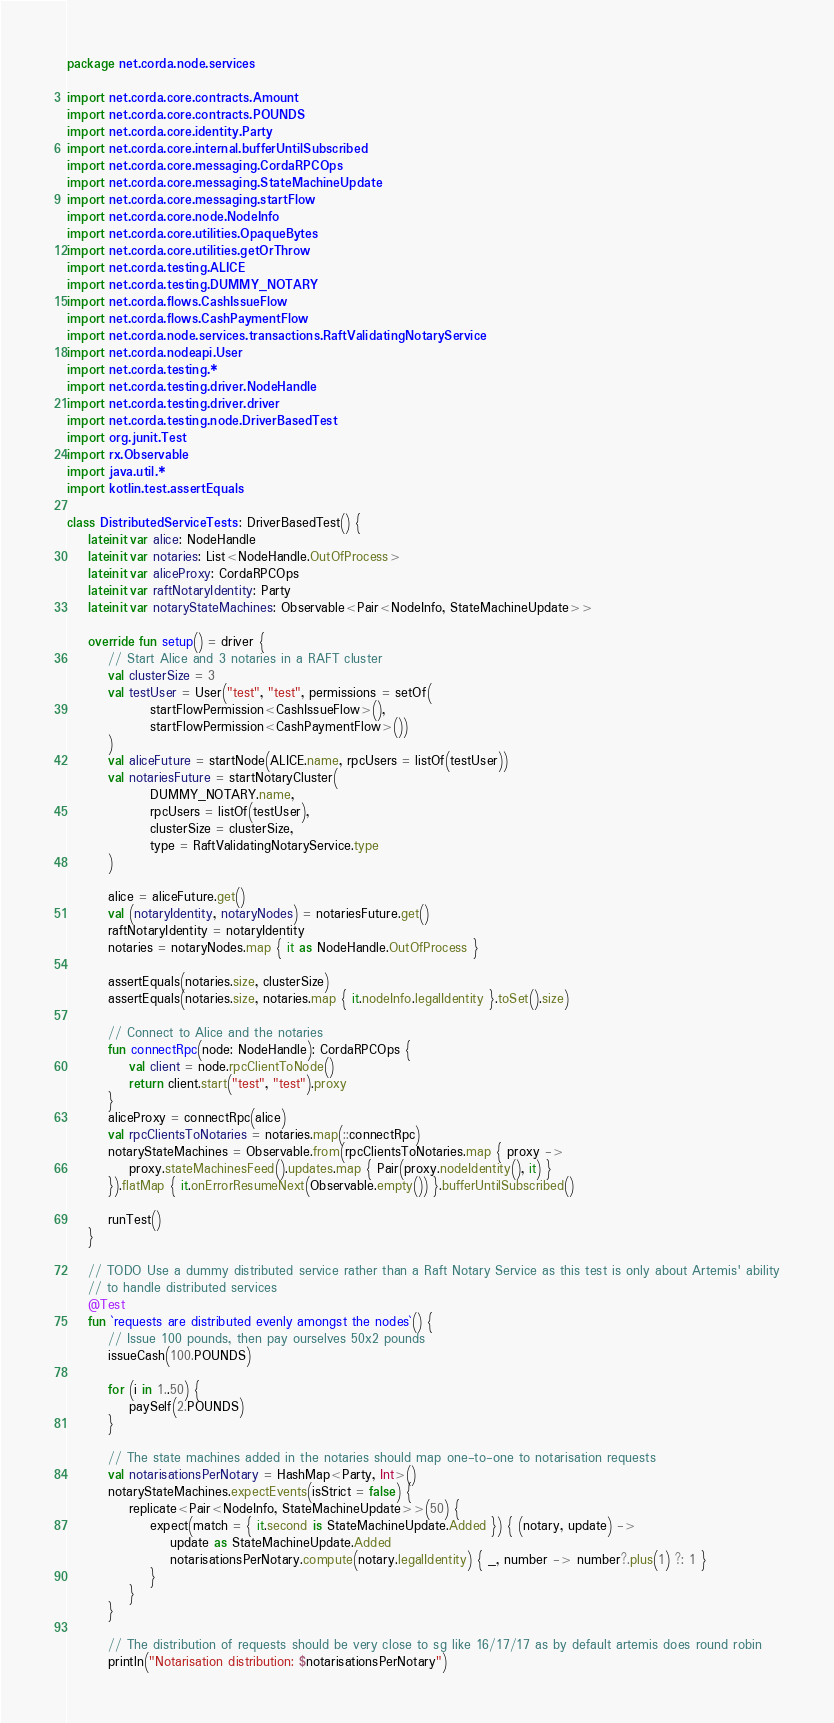Convert code to text. <code><loc_0><loc_0><loc_500><loc_500><_Kotlin_>package net.corda.node.services

import net.corda.core.contracts.Amount
import net.corda.core.contracts.POUNDS
import net.corda.core.identity.Party
import net.corda.core.internal.bufferUntilSubscribed
import net.corda.core.messaging.CordaRPCOps
import net.corda.core.messaging.StateMachineUpdate
import net.corda.core.messaging.startFlow
import net.corda.core.node.NodeInfo
import net.corda.core.utilities.OpaqueBytes
import net.corda.core.utilities.getOrThrow
import net.corda.testing.ALICE
import net.corda.testing.DUMMY_NOTARY
import net.corda.flows.CashIssueFlow
import net.corda.flows.CashPaymentFlow
import net.corda.node.services.transactions.RaftValidatingNotaryService
import net.corda.nodeapi.User
import net.corda.testing.*
import net.corda.testing.driver.NodeHandle
import net.corda.testing.driver.driver
import net.corda.testing.node.DriverBasedTest
import org.junit.Test
import rx.Observable
import java.util.*
import kotlin.test.assertEquals

class DistributedServiceTests : DriverBasedTest() {
    lateinit var alice: NodeHandle
    lateinit var notaries: List<NodeHandle.OutOfProcess>
    lateinit var aliceProxy: CordaRPCOps
    lateinit var raftNotaryIdentity: Party
    lateinit var notaryStateMachines: Observable<Pair<NodeInfo, StateMachineUpdate>>

    override fun setup() = driver {
        // Start Alice and 3 notaries in a RAFT cluster
        val clusterSize = 3
        val testUser = User("test", "test", permissions = setOf(
                startFlowPermission<CashIssueFlow>(),
                startFlowPermission<CashPaymentFlow>())
        )
        val aliceFuture = startNode(ALICE.name, rpcUsers = listOf(testUser))
        val notariesFuture = startNotaryCluster(
                DUMMY_NOTARY.name,
                rpcUsers = listOf(testUser),
                clusterSize = clusterSize,
                type = RaftValidatingNotaryService.type
        )

        alice = aliceFuture.get()
        val (notaryIdentity, notaryNodes) = notariesFuture.get()
        raftNotaryIdentity = notaryIdentity
        notaries = notaryNodes.map { it as NodeHandle.OutOfProcess }

        assertEquals(notaries.size, clusterSize)
        assertEquals(notaries.size, notaries.map { it.nodeInfo.legalIdentity }.toSet().size)

        // Connect to Alice and the notaries
        fun connectRpc(node: NodeHandle): CordaRPCOps {
            val client = node.rpcClientToNode()
            return client.start("test", "test").proxy
        }
        aliceProxy = connectRpc(alice)
        val rpcClientsToNotaries = notaries.map(::connectRpc)
        notaryStateMachines = Observable.from(rpcClientsToNotaries.map { proxy ->
            proxy.stateMachinesFeed().updates.map { Pair(proxy.nodeIdentity(), it) }
        }).flatMap { it.onErrorResumeNext(Observable.empty()) }.bufferUntilSubscribed()

        runTest()
    }

    // TODO Use a dummy distributed service rather than a Raft Notary Service as this test is only about Artemis' ability
    // to handle distributed services
    @Test
    fun `requests are distributed evenly amongst the nodes`() {
        // Issue 100 pounds, then pay ourselves 50x2 pounds
        issueCash(100.POUNDS)

        for (i in 1..50) {
            paySelf(2.POUNDS)
        }

        // The state machines added in the notaries should map one-to-one to notarisation requests
        val notarisationsPerNotary = HashMap<Party, Int>()
        notaryStateMachines.expectEvents(isStrict = false) {
            replicate<Pair<NodeInfo, StateMachineUpdate>>(50) {
                expect(match = { it.second is StateMachineUpdate.Added }) { (notary, update) ->
                    update as StateMachineUpdate.Added
                    notarisationsPerNotary.compute(notary.legalIdentity) { _, number -> number?.plus(1) ?: 1 }
                }
            }
        }

        // The distribution of requests should be very close to sg like 16/17/17 as by default artemis does round robin
        println("Notarisation distribution: $notarisationsPerNotary")</code> 